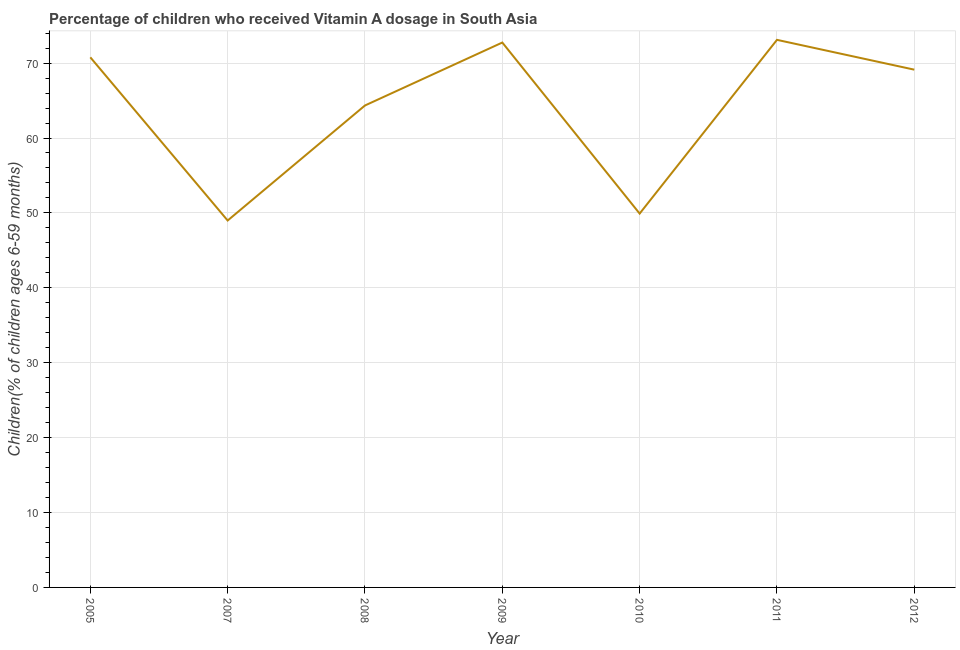What is the vitamin a supplementation coverage rate in 2008?
Your response must be concise. 64.34. Across all years, what is the maximum vitamin a supplementation coverage rate?
Give a very brief answer. 73.1. Across all years, what is the minimum vitamin a supplementation coverage rate?
Keep it short and to the point. 48.99. What is the sum of the vitamin a supplementation coverage rate?
Make the answer very short. 448.98. What is the difference between the vitamin a supplementation coverage rate in 2007 and 2008?
Provide a short and direct response. -15.36. What is the average vitamin a supplementation coverage rate per year?
Keep it short and to the point. 64.14. What is the median vitamin a supplementation coverage rate?
Give a very brief answer. 69.12. In how many years, is the vitamin a supplementation coverage rate greater than 54 %?
Offer a terse response. 5. What is the ratio of the vitamin a supplementation coverage rate in 2010 to that in 2011?
Make the answer very short. 0.68. What is the difference between the highest and the second highest vitamin a supplementation coverage rate?
Ensure brevity in your answer.  0.36. What is the difference between the highest and the lowest vitamin a supplementation coverage rate?
Offer a terse response. 24.12. In how many years, is the vitamin a supplementation coverage rate greater than the average vitamin a supplementation coverage rate taken over all years?
Provide a short and direct response. 5. How many lines are there?
Your answer should be compact. 1. How many years are there in the graph?
Make the answer very short. 7. Does the graph contain any zero values?
Keep it short and to the point. No. What is the title of the graph?
Keep it short and to the point. Percentage of children who received Vitamin A dosage in South Asia. What is the label or title of the X-axis?
Provide a succinct answer. Year. What is the label or title of the Y-axis?
Offer a terse response. Children(% of children ages 6-59 months). What is the Children(% of children ages 6-59 months) in 2005?
Give a very brief answer. 70.77. What is the Children(% of children ages 6-59 months) of 2007?
Your answer should be compact. 48.99. What is the Children(% of children ages 6-59 months) of 2008?
Your answer should be very brief. 64.34. What is the Children(% of children ages 6-59 months) of 2009?
Offer a very short reply. 72.75. What is the Children(% of children ages 6-59 months) in 2010?
Keep it short and to the point. 49.91. What is the Children(% of children ages 6-59 months) of 2011?
Keep it short and to the point. 73.1. What is the Children(% of children ages 6-59 months) in 2012?
Give a very brief answer. 69.12. What is the difference between the Children(% of children ages 6-59 months) in 2005 and 2007?
Provide a short and direct response. 21.79. What is the difference between the Children(% of children ages 6-59 months) in 2005 and 2008?
Offer a very short reply. 6.43. What is the difference between the Children(% of children ages 6-59 months) in 2005 and 2009?
Give a very brief answer. -1.97. What is the difference between the Children(% of children ages 6-59 months) in 2005 and 2010?
Provide a succinct answer. 20.86. What is the difference between the Children(% of children ages 6-59 months) in 2005 and 2011?
Keep it short and to the point. -2.33. What is the difference between the Children(% of children ages 6-59 months) in 2005 and 2012?
Ensure brevity in your answer.  1.65. What is the difference between the Children(% of children ages 6-59 months) in 2007 and 2008?
Make the answer very short. -15.36. What is the difference between the Children(% of children ages 6-59 months) in 2007 and 2009?
Give a very brief answer. -23.76. What is the difference between the Children(% of children ages 6-59 months) in 2007 and 2010?
Ensure brevity in your answer.  -0.92. What is the difference between the Children(% of children ages 6-59 months) in 2007 and 2011?
Offer a very short reply. -24.12. What is the difference between the Children(% of children ages 6-59 months) in 2007 and 2012?
Provide a succinct answer. -20.14. What is the difference between the Children(% of children ages 6-59 months) in 2008 and 2009?
Provide a short and direct response. -8.4. What is the difference between the Children(% of children ages 6-59 months) in 2008 and 2010?
Provide a succinct answer. 14.43. What is the difference between the Children(% of children ages 6-59 months) in 2008 and 2011?
Your response must be concise. -8.76. What is the difference between the Children(% of children ages 6-59 months) in 2008 and 2012?
Your response must be concise. -4.78. What is the difference between the Children(% of children ages 6-59 months) in 2009 and 2010?
Keep it short and to the point. 22.84. What is the difference between the Children(% of children ages 6-59 months) in 2009 and 2011?
Offer a very short reply. -0.36. What is the difference between the Children(% of children ages 6-59 months) in 2009 and 2012?
Provide a short and direct response. 3.62. What is the difference between the Children(% of children ages 6-59 months) in 2010 and 2011?
Your answer should be very brief. -23.19. What is the difference between the Children(% of children ages 6-59 months) in 2010 and 2012?
Offer a very short reply. -19.21. What is the difference between the Children(% of children ages 6-59 months) in 2011 and 2012?
Your response must be concise. 3.98. What is the ratio of the Children(% of children ages 6-59 months) in 2005 to that in 2007?
Keep it short and to the point. 1.45. What is the ratio of the Children(% of children ages 6-59 months) in 2005 to that in 2008?
Provide a short and direct response. 1.1. What is the ratio of the Children(% of children ages 6-59 months) in 2005 to that in 2009?
Your response must be concise. 0.97. What is the ratio of the Children(% of children ages 6-59 months) in 2005 to that in 2010?
Offer a very short reply. 1.42. What is the ratio of the Children(% of children ages 6-59 months) in 2005 to that in 2011?
Make the answer very short. 0.97. What is the ratio of the Children(% of children ages 6-59 months) in 2007 to that in 2008?
Your response must be concise. 0.76. What is the ratio of the Children(% of children ages 6-59 months) in 2007 to that in 2009?
Offer a terse response. 0.67. What is the ratio of the Children(% of children ages 6-59 months) in 2007 to that in 2010?
Your answer should be very brief. 0.98. What is the ratio of the Children(% of children ages 6-59 months) in 2007 to that in 2011?
Provide a short and direct response. 0.67. What is the ratio of the Children(% of children ages 6-59 months) in 2007 to that in 2012?
Keep it short and to the point. 0.71. What is the ratio of the Children(% of children ages 6-59 months) in 2008 to that in 2009?
Provide a short and direct response. 0.89. What is the ratio of the Children(% of children ages 6-59 months) in 2008 to that in 2010?
Offer a terse response. 1.29. What is the ratio of the Children(% of children ages 6-59 months) in 2009 to that in 2010?
Provide a short and direct response. 1.46. What is the ratio of the Children(% of children ages 6-59 months) in 2009 to that in 2012?
Your answer should be very brief. 1.05. What is the ratio of the Children(% of children ages 6-59 months) in 2010 to that in 2011?
Your answer should be compact. 0.68. What is the ratio of the Children(% of children ages 6-59 months) in 2010 to that in 2012?
Make the answer very short. 0.72. What is the ratio of the Children(% of children ages 6-59 months) in 2011 to that in 2012?
Your answer should be very brief. 1.06. 